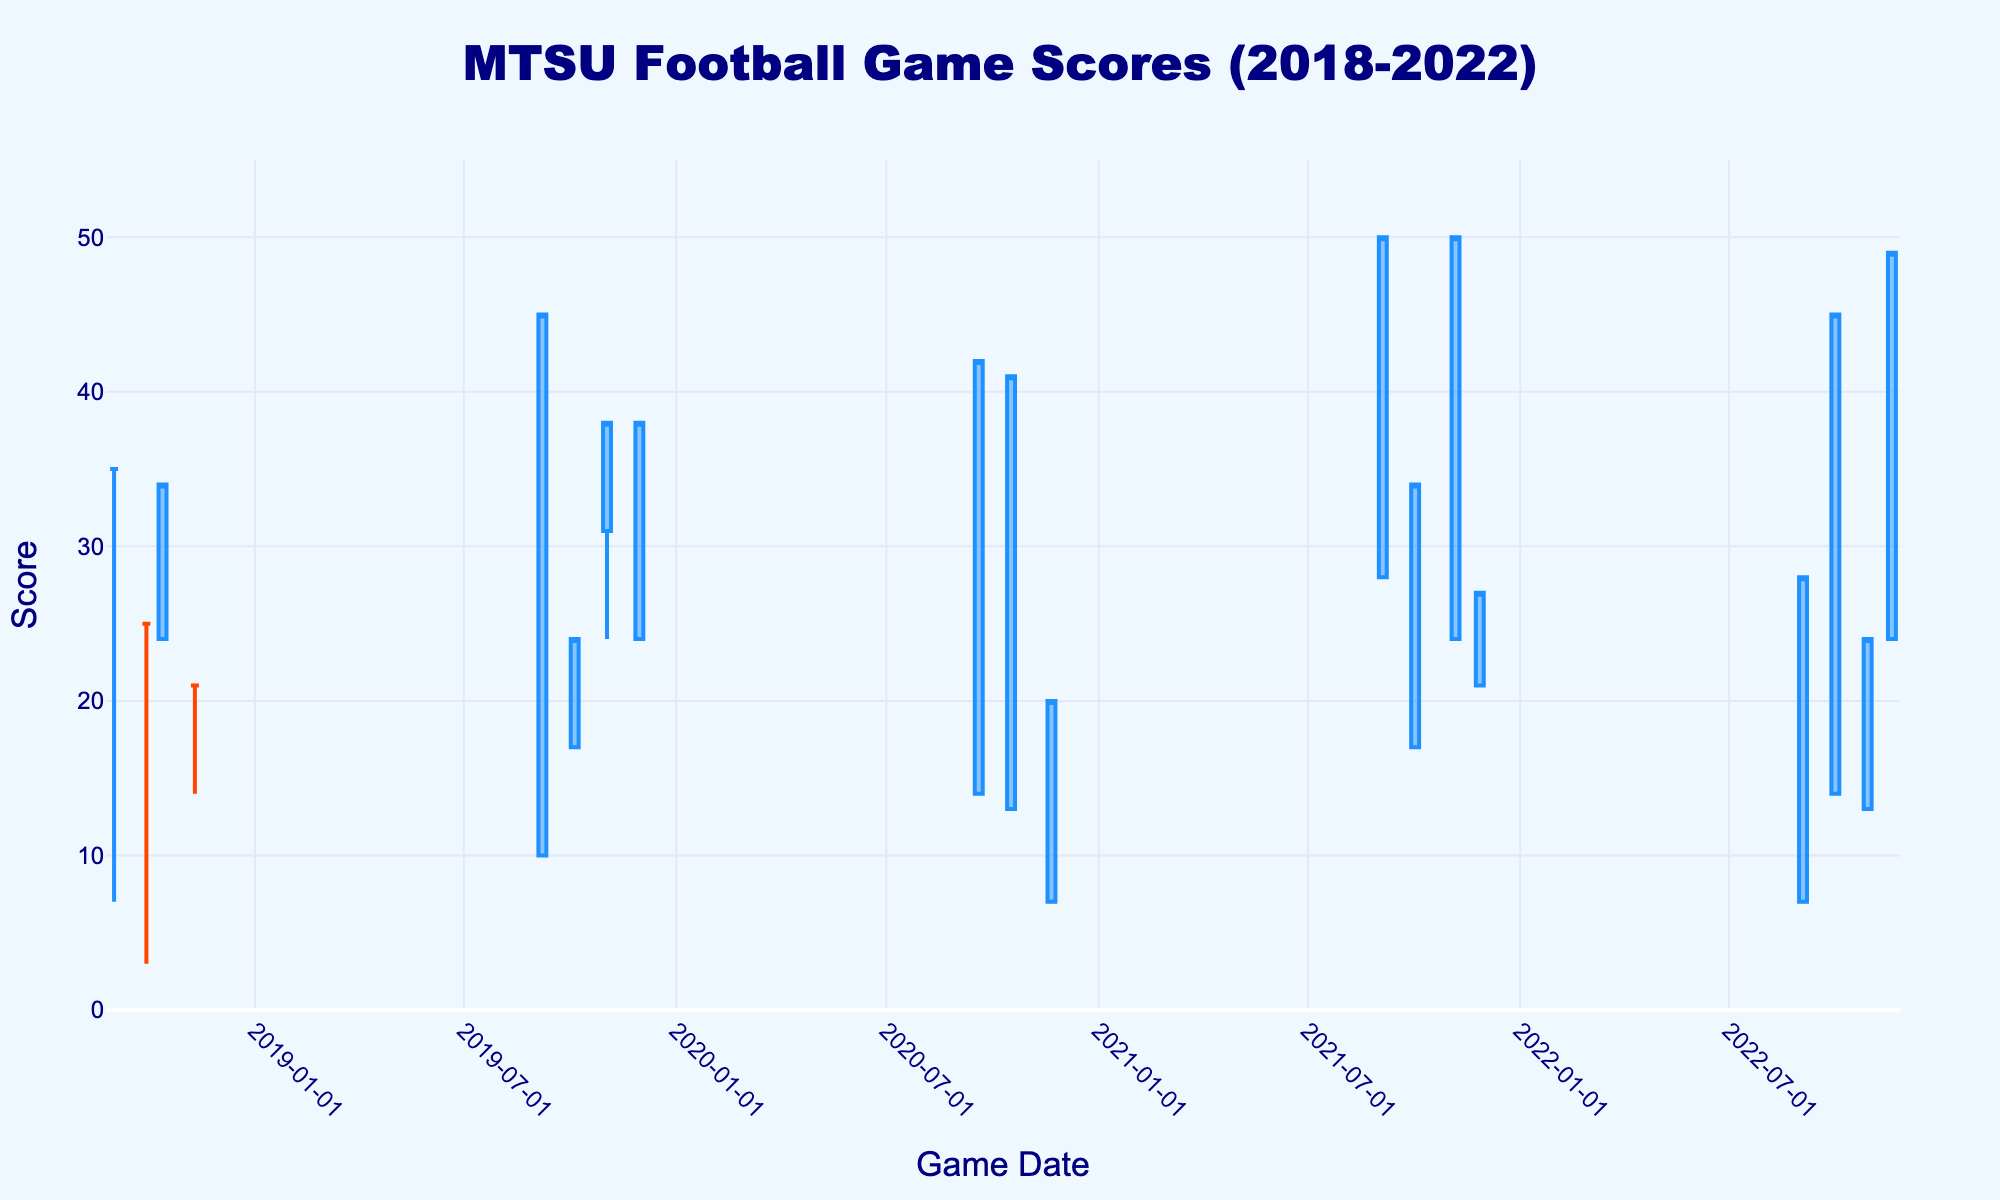What is the title of the chart? The title is located at the top center of the chart. It reads "MTSU Football Game Scores (2018-2022)".
Answer: MTSU Football Game Scores (2018-2022) What are the highest and lowest scores in the chart? To find the highest and lowest scores, identify the highest and lowest points on the y-axis. The highest score shown is 50, and the lowest is 3.
Answer: Highest: 50, Lowest: 3 On which date did MTSU achieve a closing score of 50? Look for the highest orange or blue bar on the chart and identify the corresponding date on the x-axis. The games on 2021-09-04 and 2021-11-06 both have a closing score of 50.
Answer: 2021-09-04 and 2021-11-06 What is the average closing score for the games shown in 2020? List the closing scores for the games in 2020: 42, 41, 20. The average is (42 + 41 + 20) / 3 = 103 / 3 ≈ 34.33.
Answer: 34.33 Compare the highest scores between 2019 and 2022. Which year had the higher peak? Identify the highest point of each year's range. For 2019, the highest score is 45. For 2022, the highest score is 49. Therefore, 2022 had the higher peak.
Answer: 2022 Did MTSU have any games where the opening and closing scores were the same? Observe the OHLC bars where the open score (left line) and close score (right line) are at the same level. The games on 2018-09-01, 2018-09-29, 2018-11-10, and 2019-09-07 meet this criterion.
Answer: Yes What was the range (difference between high and low) of the scores in the game on 2018-10-13? The high score on this date is 34, and the low score is 24. The range is calculated as 34 - 24 = 10.
Answer: 10 How many games had a low score below 20? Count the number of OHLC bars where the lowest point is below 20. The dates that meet this condition are: 2018-09-01, 2018-09-29, 2018-11-10, 2019-09-07, 2020-09-19, 2020-10-17, 2020-11-21, 2022-09-03, 2022-10-01, 2022-10-29. There are 10 such games.
Answer: 10 Compare the closing scores of the first and last game in the dataset. Which one was higher? Look at the first game date, 2018-09-01 (closing score 35), and the last game date, 2022-11-19 (closing score 49). The closing score on 2022-11-19 is higher.
Answer: 2022-11-19 